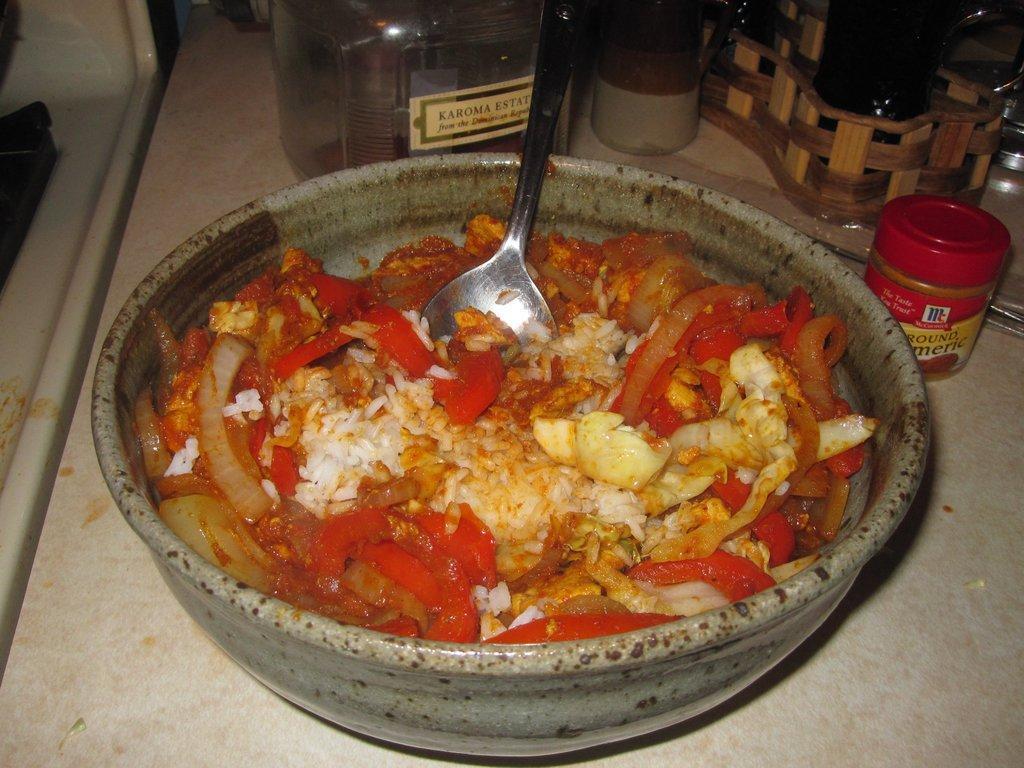How would you summarize this image in a sentence or two? In this picture we can see a bowl in the front, there is some food and a spoon in this bowl, in the background there are bottles and a tray. 